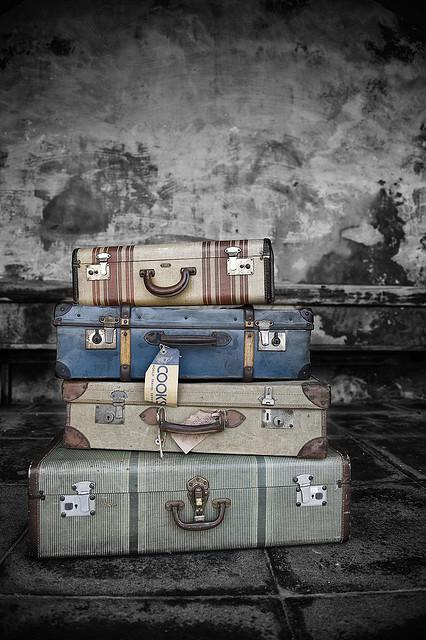How many suitcases have vertical stripes running down them?
Write a very short answer. 3. What color is the case closest to the camera?
Give a very brief answer. Gray. How many people are shown?
Write a very short answer. 0. What color is the case?
Quick response, please. Blue. What color is the suitcase that is third from the bottom?
Keep it brief. Blue. How many suitcases are there?
Be succinct. 4. Are the suitcases for sale?
Give a very brief answer. No. 